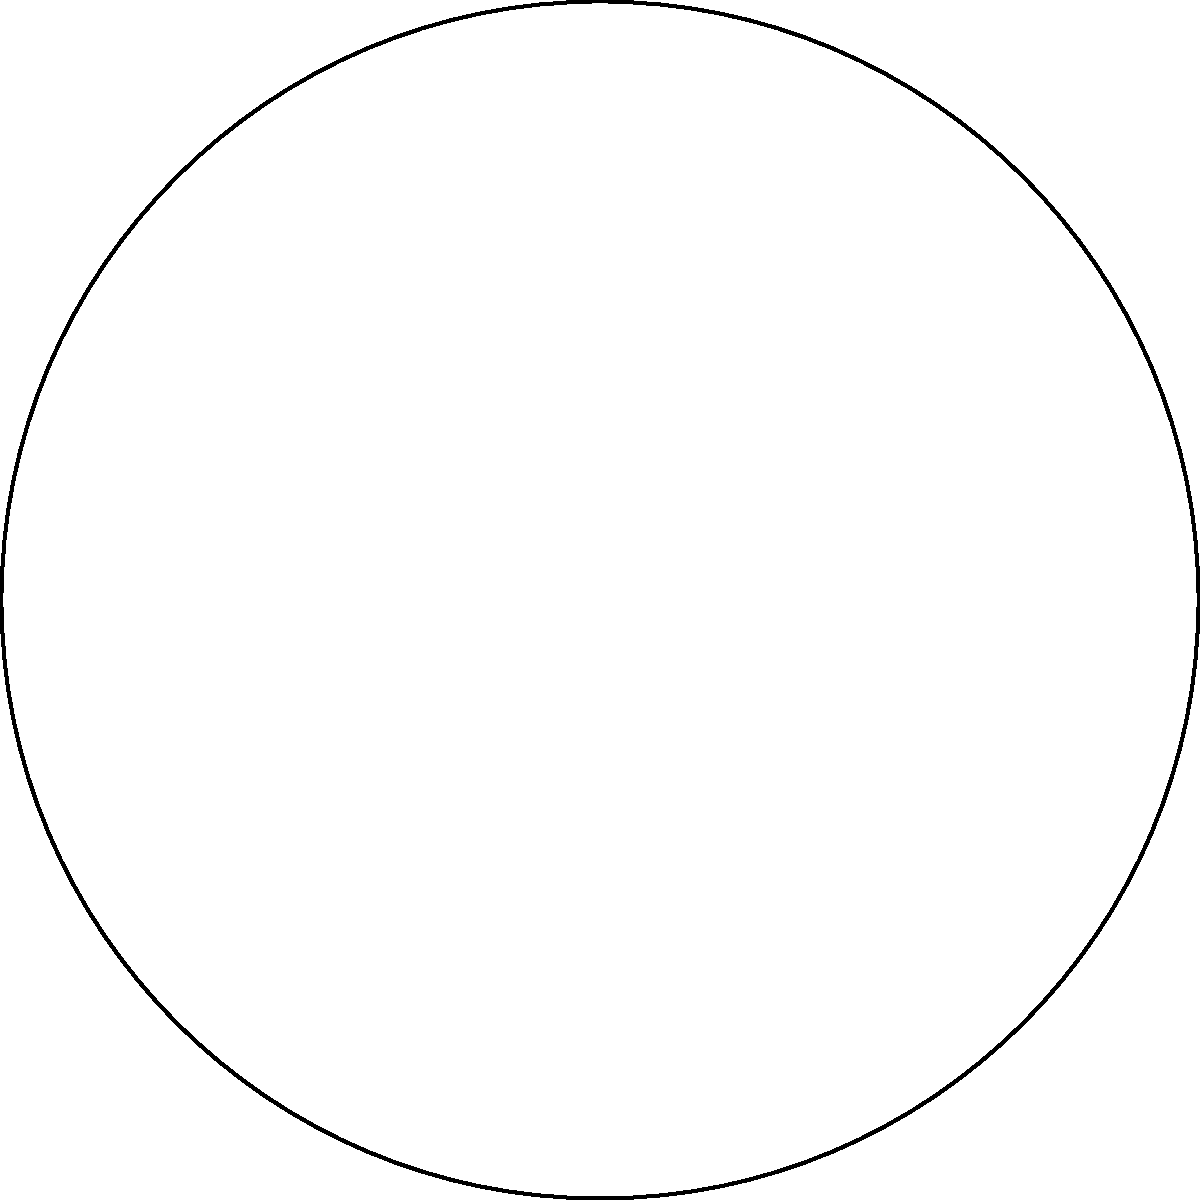In a circular tribal council meeting area with a radius of 30 feet, eight council members are seated equidistantly around the perimeter. If the first council member is seated at the point (30, 0) and the angle between each member is 45°, what are the coordinates (x, y) of the third council member? Express your answer in terms of sine and cosine functions. Let's approach this step-by-step:

1) The circle has a radius of 30 feet, and there are 8 council members equally spaced around the circle.

2) The angle between each member is 360° / 8 = 45°.

3) The first member is at (30, 0), which corresponds to an angle of 0°.

4) The third member will be at an angle of 2 * 45° = 90° from the first member.

5) In a circle, the x-coordinate is given by $r \cos(\theta)$ and the y-coordinate by $r \sin(\theta)$, where $r$ is the radius and $\theta$ is the angle from the positive x-axis.

6) For the third member:
   $x = 30 \cos(90°) = 30 \cos(\frac{\pi}{2}) = 0$
   $y = 30 \sin(90°) = 30 \sin(\frac{\pi}{2}) = 30$

7) Therefore, the coordinates of the third council member are (0, 30).

8) Expressing this in terms of sine and cosine functions:
   $x = 30 \cos(\frac{\pi}{2})$
   $y = 30 \sin(\frac{\pi}{2})$
Answer: $(30 \cos(\frac{\pi}{2}), 30 \sin(\frac{\pi}{2}))$ 